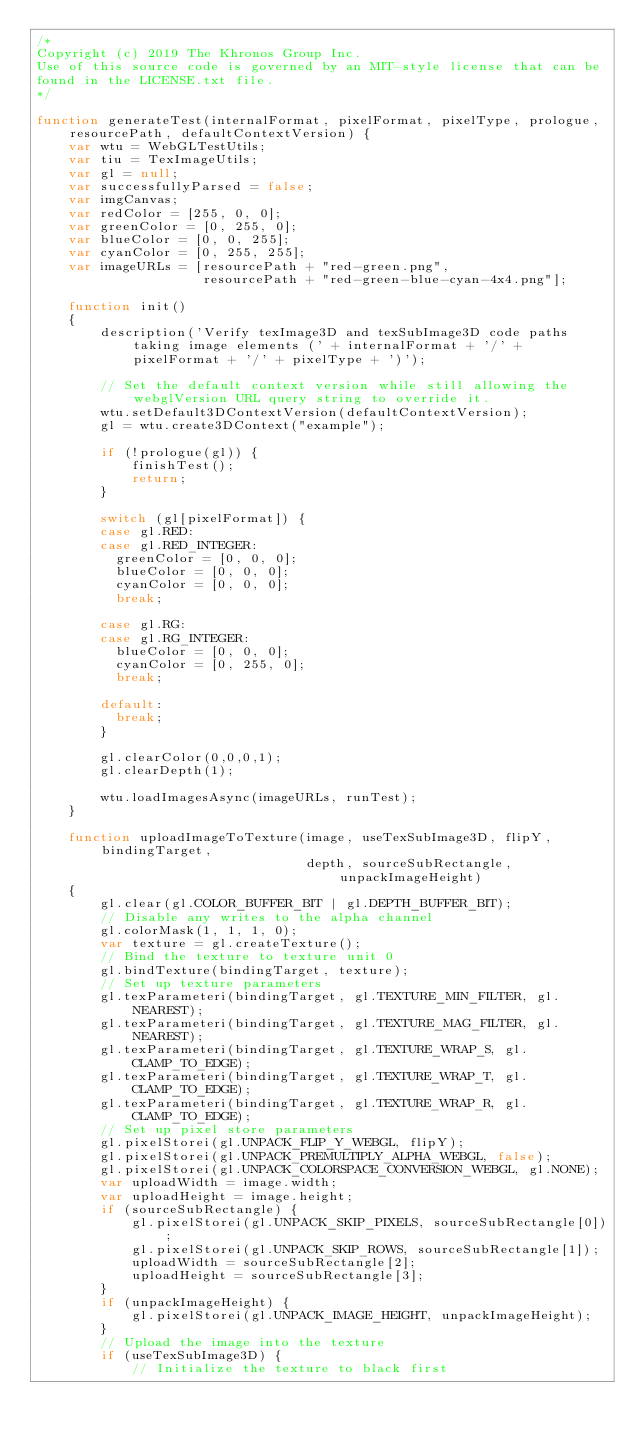Convert code to text. <code><loc_0><loc_0><loc_500><loc_500><_JavaScript_>/*
Copyright (c) 2019 The Khronos Group Inc.
Use of this source code is governed by an MIT-style license that can be
found in the LICENSE.txt file.
*/

function generateTest(internalFormat, pixelFormat, pixelType, prologue, resourcePath, defaultContextVersion) {
    var wtu = WebGLTestUtils;
    var tiu = TexImageUtils;
    var gl = null;
    var successfullyParsed = false;
    var imgCanvas;
    var redColor = [255, 0, 0];
    var greenColor = [0, 255, 0];
    var blueColor = [0, 0, 255];
    var cyanColor = [0, 255, 255];
    var imageURLs = [resourcePath + "red-green.png",
                     resourcePath + "red-green-blue-cyan-4x4.png"];

    function init()
    {
        description('Verify texImage3D and texSubImage3D code paths taking image elements (' + internalFormat + '/' + pixelFormat + '/' + pixelType + ')');

        // Set the default context version while still allowing the webglVersion URL query string to override it.
        wtu.setDefault3DContextVersion(defaultContextVersion);
        gl = wtu.create3DContext("example");

        if (!prologue(gl)) {
            finishTest();
            return;
        }

        switch (gl[pixelFormat]) {
        case gl.RED:
        case gl.RED_INTEGER:
          greenColor = [0, 0, 0];
          blueColor = [0, 0, 0];
          cyanColor = [0, 0, 0];
          break;

        case gl.RG:
        case gl.RG_INTEGER:
          blueColor = [0, 0, 0];
          cyanColor = [0, 255, 0];
          break;

        default:
          break;
        }

        gl.clearColor(0,0,0,1);
        gl.clearDepth(1);

        wtu.loadImagesAsync(imageURLs, runTest);
    }

    function uploadImageToTexture(image, useTexSubImage3D, flipY, bindingTarget,
                                  depth, sourceSubRectangle, unpackImageHeight)
    {
        gl.clear(gl.COLOR_BUFFER_BIT | gl.DEPTH_BUFFER_BIT);
        // Disable any writes to the alpha channel
        gl.colorMask(1, 1, 1, 0);
        var texture = gl.createTexture();
        // Bind the texture to texture unit 0
        gl.bindTexture(bindingTarget, texture);
        // Set up texture parameters
        gl.texParameteri(bindingTarget, gl.TEXTURE_MIN_FILTER, gl.NEAREST);
        gl.texParameteri(bindingTarget, gl.TEXTURE_MAG_FILTER, gl.NEAREST);
        gl.texParameteri(bindingTarget, gl.TEXTURE_WRAP_S, gl.CLAMP_TO_EDGE);
        gl.texParameteri(bindingTarget, gl.TEXTURE_WRAP_T, gl.CLAMP_TO_EDGE);
        gl.texParameteri(bindingTarget, gl.TEXTURE_WRAP_R, gl.CLAMP_TO_EDGE);
        // Set up pixel store parameters
        gl.pixelStorei(gl.UNPACK_FLIP_Y_WEBGL, flipY);
        gl.pixelStorei(gl.UNPACK_PREMULTIPLY_ALPHA_WEBGL, false);
        gl.pixelStorei(gl.UNPACK_COLORSPACE_CONVERSION_WEBGL, gl.NONE);
        var uploadWidth = image.width;
        var uploadHeight = image.height;
        if (sourceSubRectangle) {
            gl.pixelStorei(gl.UNPACK_SKIP_PIXELS, sourceSubRectangle[0]);
            gl.pixelStorei(gl.UNPACK_SKIP_ROWS, sourceSubRectangle[1]);
            uploadWidth = sourceSubRectangle[2];
            uploadHeight = sourceSubRectangle[3];
        }
        if (unpackImageHeight) {
            gl.pixelStorei(gl.UNPACK_IMAGE_HEIGHT, unpackImageHeight);
        }
        // Upload the image into the texture
        if (useTexSubImage3D) {
            // Initialize the texture to black first</code> 